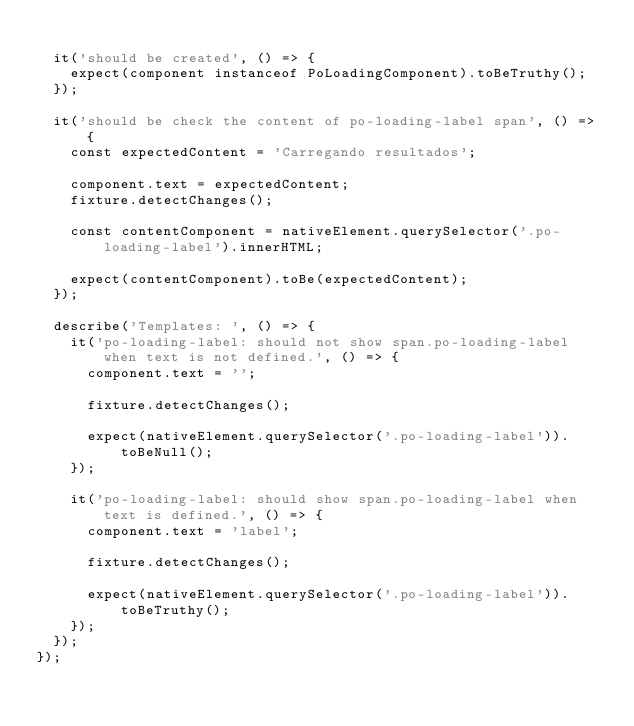Convert code to text. <code><loc_0><loc_0><loc_500><loc_500><_TypeScript_>
  it('should be created', () => {
    expect(component instanceof PoLoadingComponent).toBeTruthy();
  });

  it('should be check the content of po-loading-label span', () => {
    const expectedContent = 'Carregando resultados';

    component.text = expectedContent;
    fixture.detectChanges();

    const contentComponent = nativeElement.querySelector('.po-loading-label').innerHTML;

    expect(contentComponent).toBe(expectedContent);
  });

  describe('Templates: ', () => {
    it('po-loading-label: should not show span.po-loading-label when text is not defined.', () => {
      component.text = '';

      fixture.detectChanges();

      expect(nativeElement.querySelector('.po-loading-label')).toBeNull();
    });

    it('po-loading-label: should show span.po-loading-label when text is defined.', () => {
      component.text = 'label';

      fixture.detectChanges();

      expect(nativeElement.querySelector('.po-loading-label')).toBeTruthy();
    });
  });
});
</code> 